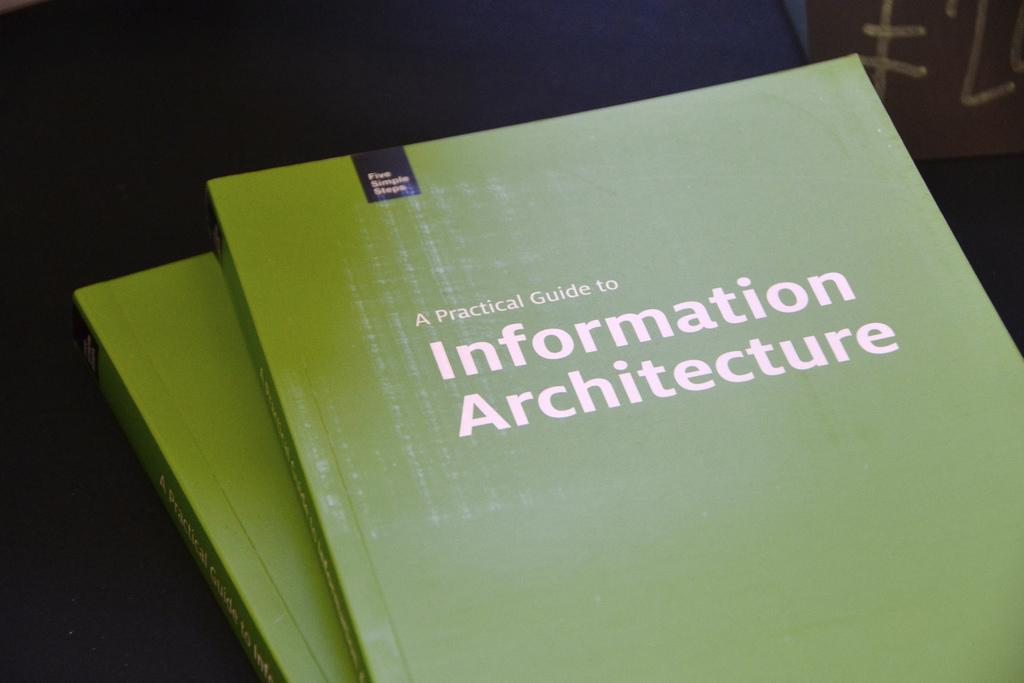<image>
Render a clear and concise summary of the photo. a green book with the title Information Architecture 